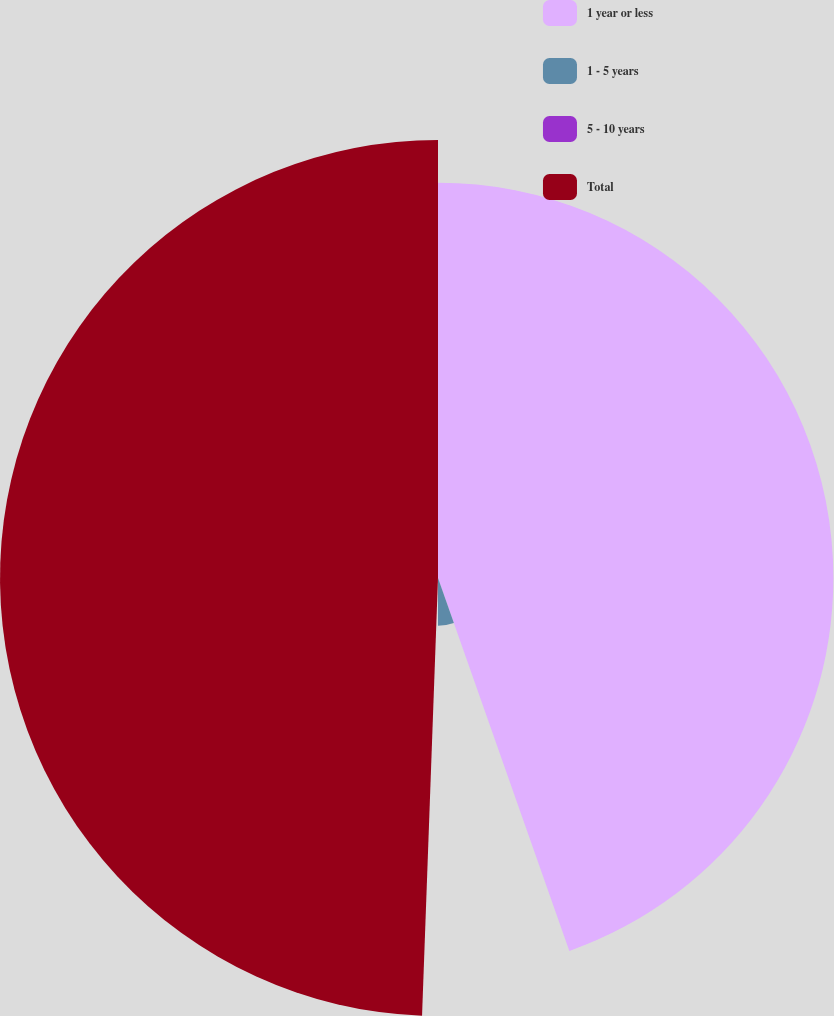<chart> <loc_0><loc_0><loc_500><loc_500><pie_chart><fcel>1 year or less<fcel>1 - 5 years<fcel>5 - 10 years<fcel>Total<nl><fcel>44.61%<fcel>5.39%<fcel>0.58%<fcel>49.42%<nl></chart> 